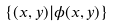<formula> <loc_0><loc_0><loc_500><loc_500>\{ ( x , y ) | \phi ( x , y ) \}</formula> 